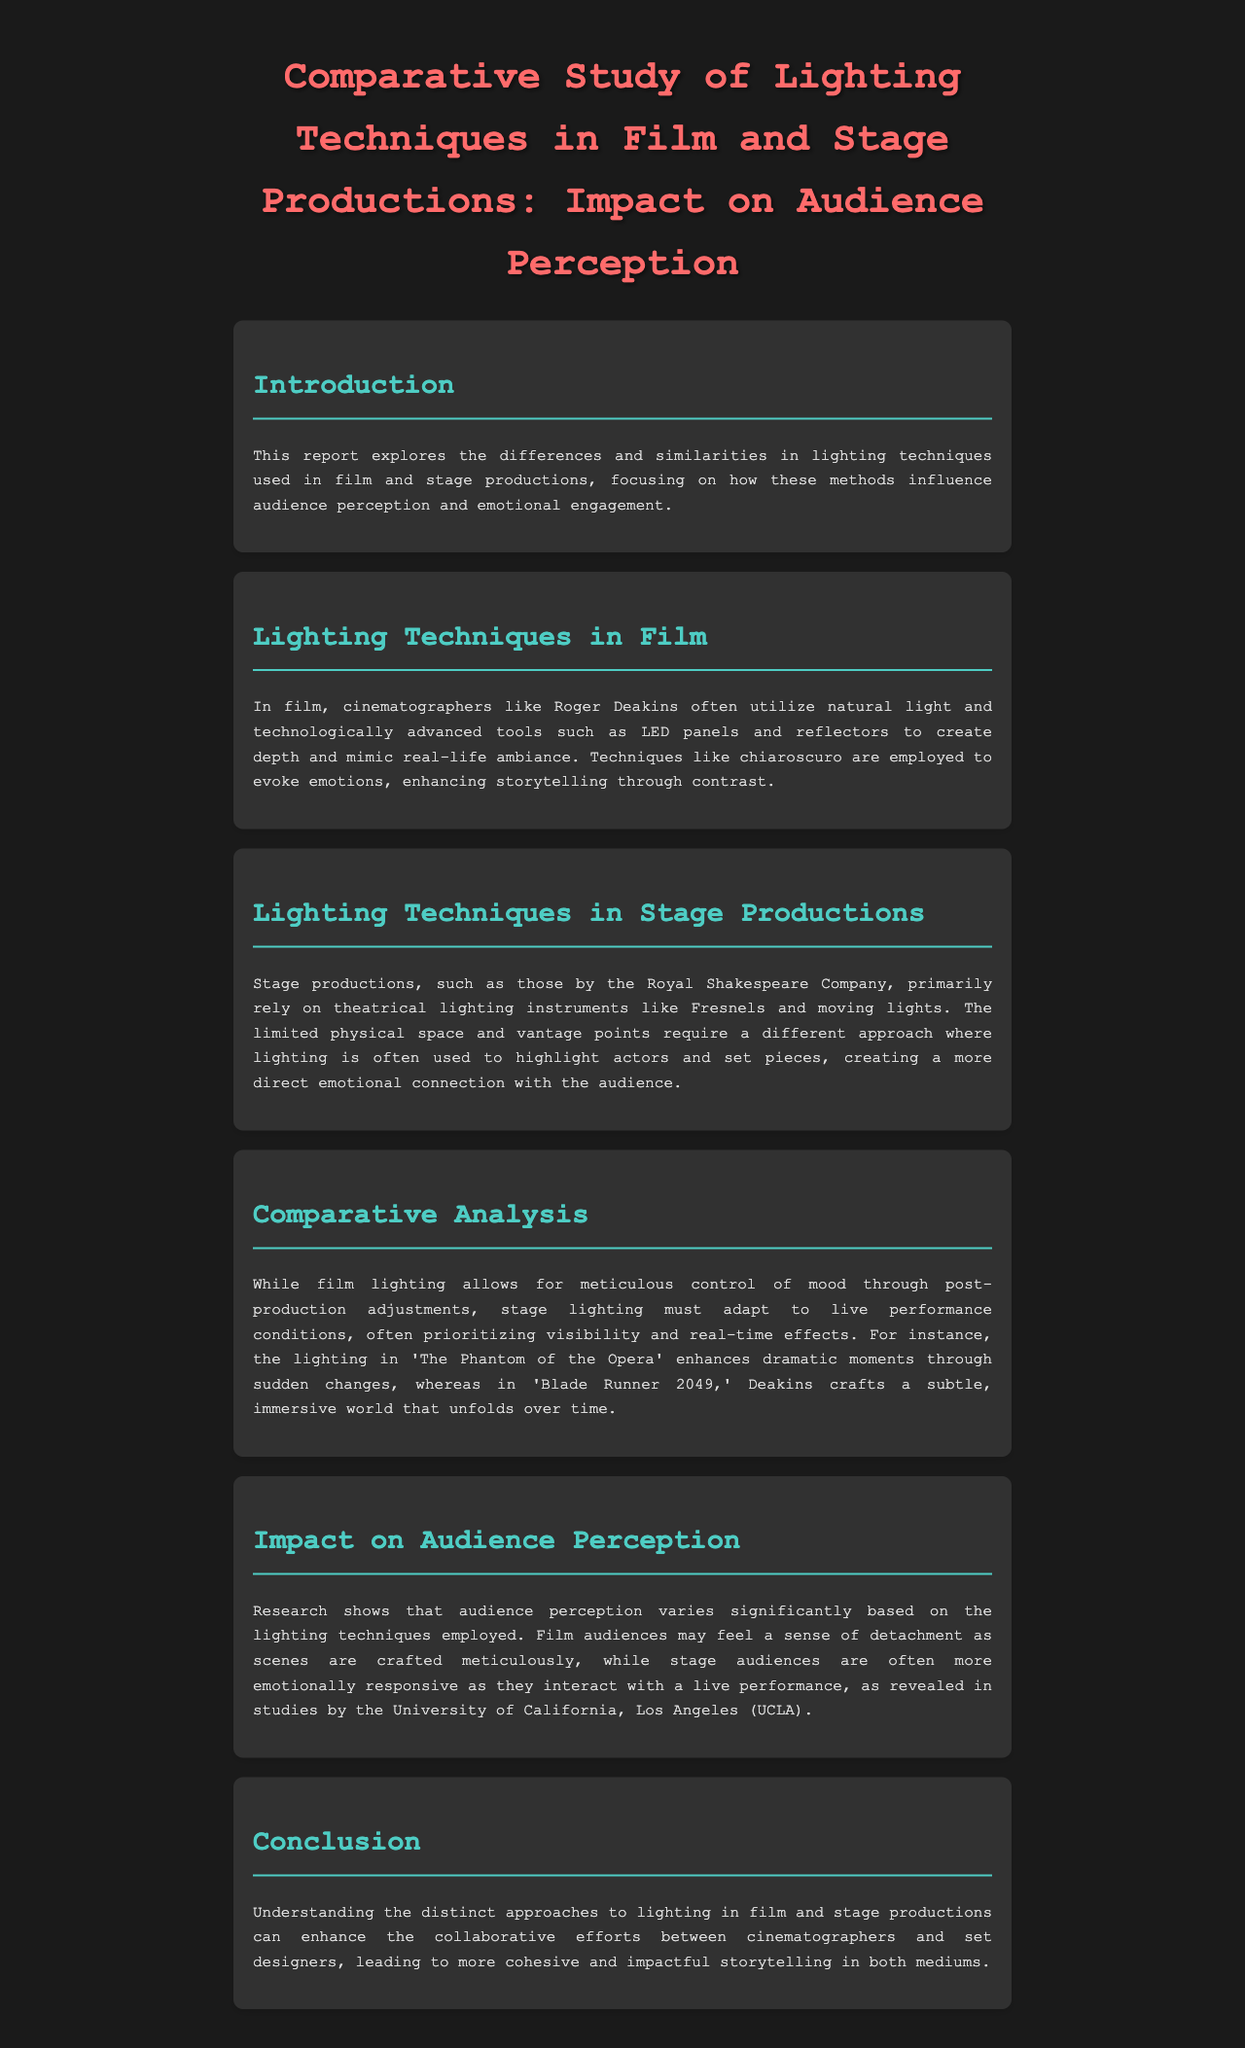What is the main focus of this report? The main focus of the report is the differences and similarities in lighting techniques used in film and stage productions and their influence on audience perception and emotional engagement.
Answer: audience perception Who is a notable cinematographer mentioned in the document? The report mentions Roger Deakins as a notable cinematographer.
Answer: Roger Deakins What lighting instrument is primarily used in stage productions according to the report? The report states that theatrical lighting instruments like Fresnels are primarily used in stage productions.
Answer: Fresnels Which theatrical production is referenced in the comparative analysis? The comparative analysis references 'The Phantom of the Opera.'
Answer: The Phantom of the Opera What is the conclusion of the report regarding cinematographers and set designers? The conclusion states that understanding distinct lighting approaches can enhance collaboration between cinematographers and set designers.
Answer: collaboration How does audience perception vary between film and stage productions? The document explains that film audiences may feel a sense of detachment, while stage audiences are more emotionally responsive.
Answer: detachment vs. emotional responsiveness 